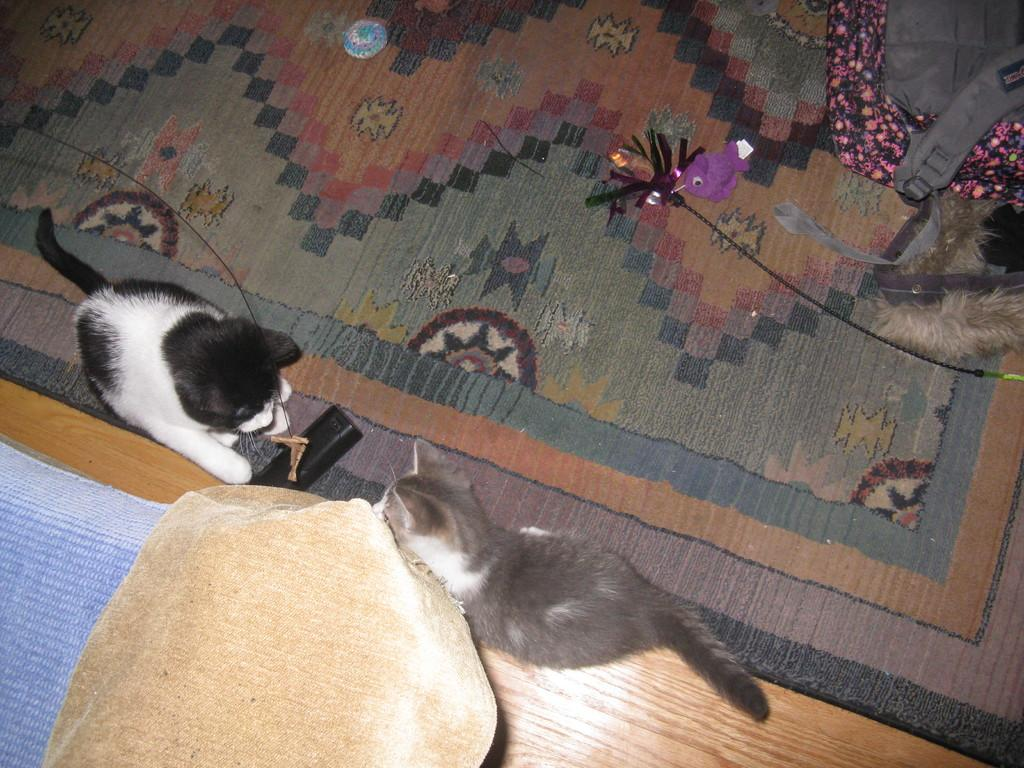How many cats are in the image? There are two cats in the image. What is located at the bottom of the image? There is a floor mat at the bottom of the image. Where is the bed positioned in the image? The bed is on the left side of the image. What is on the right side of the image? There is a bag on the right side of the image. What type of road can be seen in the image? There is no road present in the image. What system is being used by the cats to communicate in the image? The cats do not appear to be using any communication system in the image. 